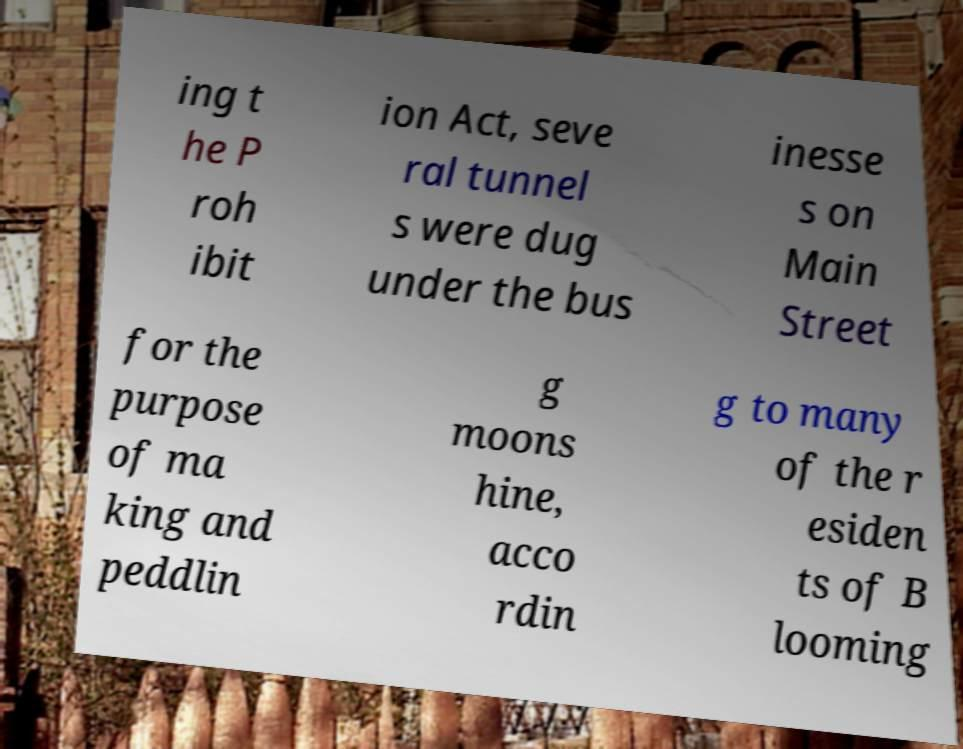Can you accurately transcribe the text from the provided image for me? ing t he P roh ibit ion Act, seve ral tunnel s were dug under the bus inesse s on Main Street for the purpose of ma king and peddlin g moons hine, acco rdin g to many of the r esiden ts of B looming 